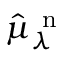<formula> <loc_0><loc_0><loc_500><loc_500>\hat { \mu } _ { \lambda } ^ { n }</formula> 